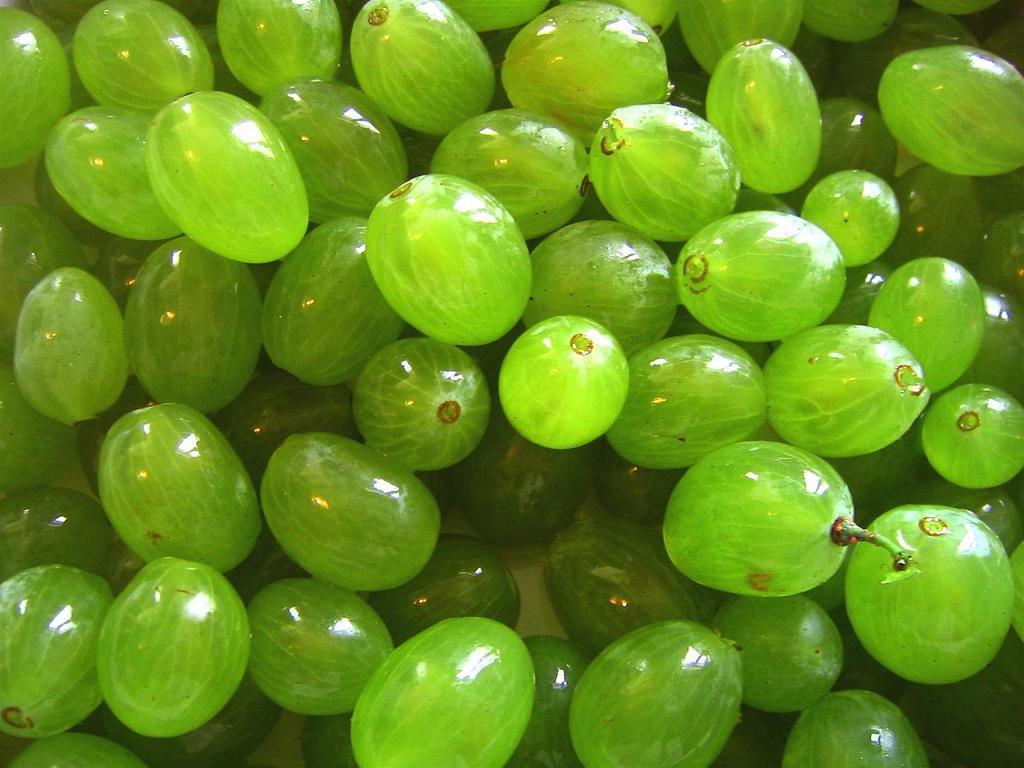In one or two sentences, can you explain what this image depicts? There are green color grapes arranged on a surface. And the background is white in color. 